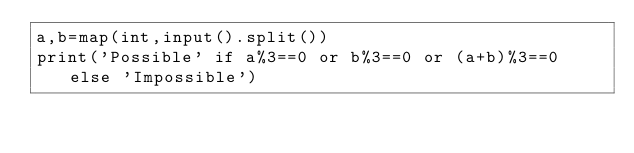<code> <loc_0><loc_0><loc_500><loc_500><_Python_>a,b=map(int,input().split())
print('Possible' if a%3==0 or b%3==0 or (a+b)%3==0 else 'Impossible')
</code> 